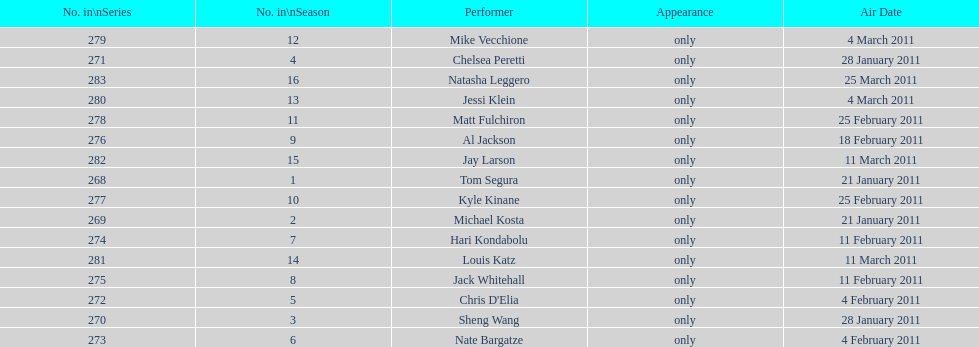Which month had the most air dates? February. 